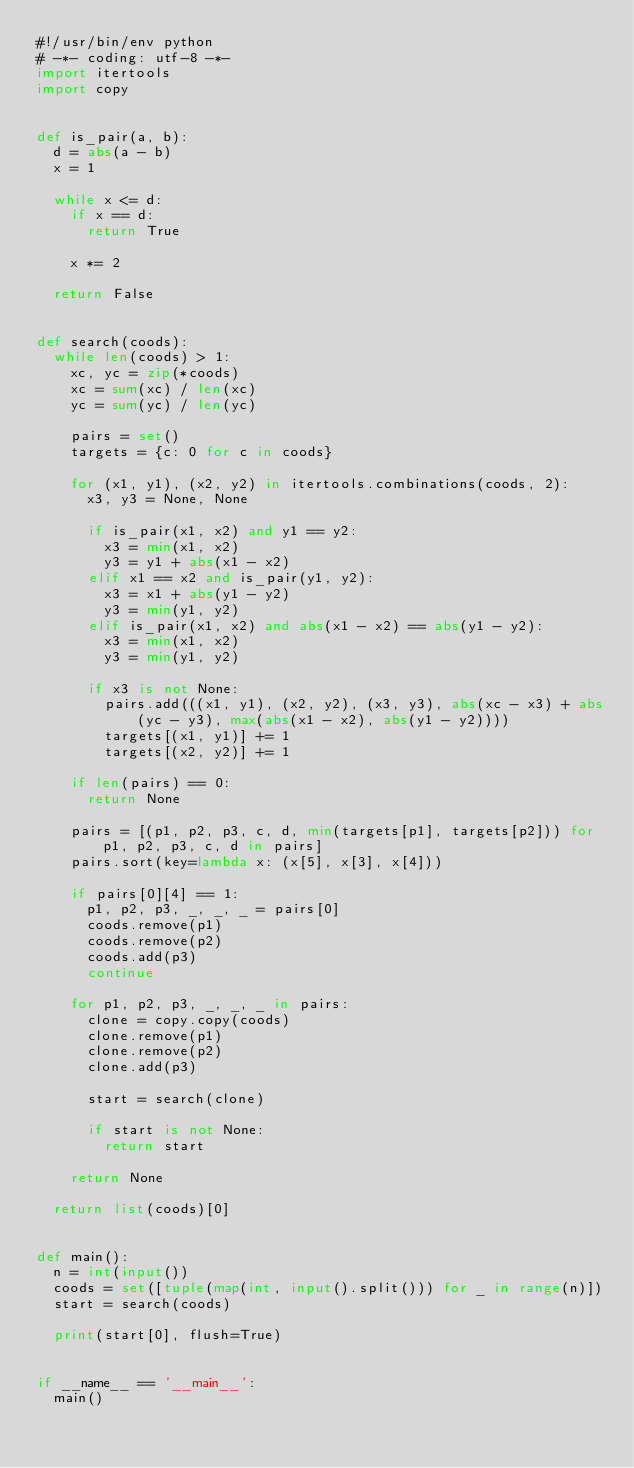Convert code to text. <code><loc_0><loc_0><loc_500><loc_500><_Python_>#!/usr/bin/env python
# -*- coding: utf-8 -*-
import itertools
import copy


def is_pair(a, b):
  d = abs(a - b)
  x = 1

  while x <= d:
    if x == d:
      return True

    x *= 2

  return False


def search(coods):
  while len(coods) > 1:
    xc, yc = zip(*coods)
    xc = sum(xc) / len(xc)
    yc = sum(yc) / len(yc)

    pairs = set()
    targets = {c: 0 for c in coods}

    for (x1, y1), (x2, y2) in itertools.combinations(coods, 2):
      x3, y3 = None, None

      if is_pair(x1, x2) and y1 == y2:
        x3 = min(x1, x2)
        y3 = y1 + abs(x1 - x2)
      elif x1 == x2 and is_pair(y1, y2):
        x3 = x1 + abs(y1 - y2)
        y3 = min(y1, y2)
      elif is_pair(x1, x2) and abs(x1 - x2) == abs(y1 - y2):
        x3 = min(x1, x2)
        y3 = min(y1, y2)

      if x3 is not None:
        pairs.add(((x1, y1), (x2, y2), (x3, y3), abs(xc - x3) + abs(yc - y3), max(abs(x1 - x2), abs(y1 - y2))))
        targets[(x1, y1)] += 1
        targets[(x2, y2)] += 1

    if len(pairs) == 0:
      return None

    pairs = [(p1, p2, p3, c, d, min(targets[p1], targets[p2])) for p1, p2, p3, c, d in pairs]
    pairs.sort(key=lambda x: (x[5], x[3], x[4]))

    if pairs[0][4] == 1:
      p1, p2, p3, _, _, _ = pairs[0]
      coods.remove(p1)
      coods.remove(p2)
      coods.add(p3)
      continue

    for p1, p2, p3, _, _, _ in pairs:
      clone = copy.copy(coods)
      clone.remove(p1)
      clone.remove(p2)
      clone.add(p3)

      start = search(clone)

      if start is not None:
        return start

    return None

  return list(coods)[0]


def main():
  n = int(input())
  coods = set([tuple(map(int, input().split())) for _ in range(n)])
  start = search(coods)

  print(start[0], flush=True)


if __name__ == '__main__':
  main()

</code> 